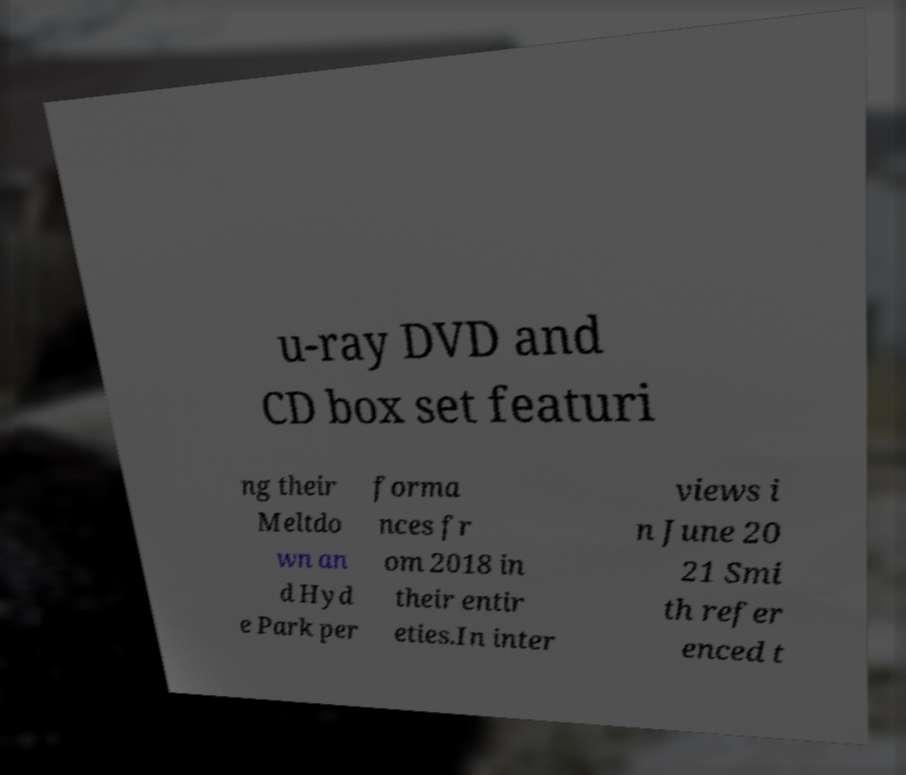There's text embedded in this image that I need extracted. Can you transcribe it verbatim? u-ray DVD and CD box set featuri ng their Meltdo wn an d Hyd e Park per forma nces fr om 2018 in their entir eties.In inter views i n June 20 21 Smi th refer enced t 